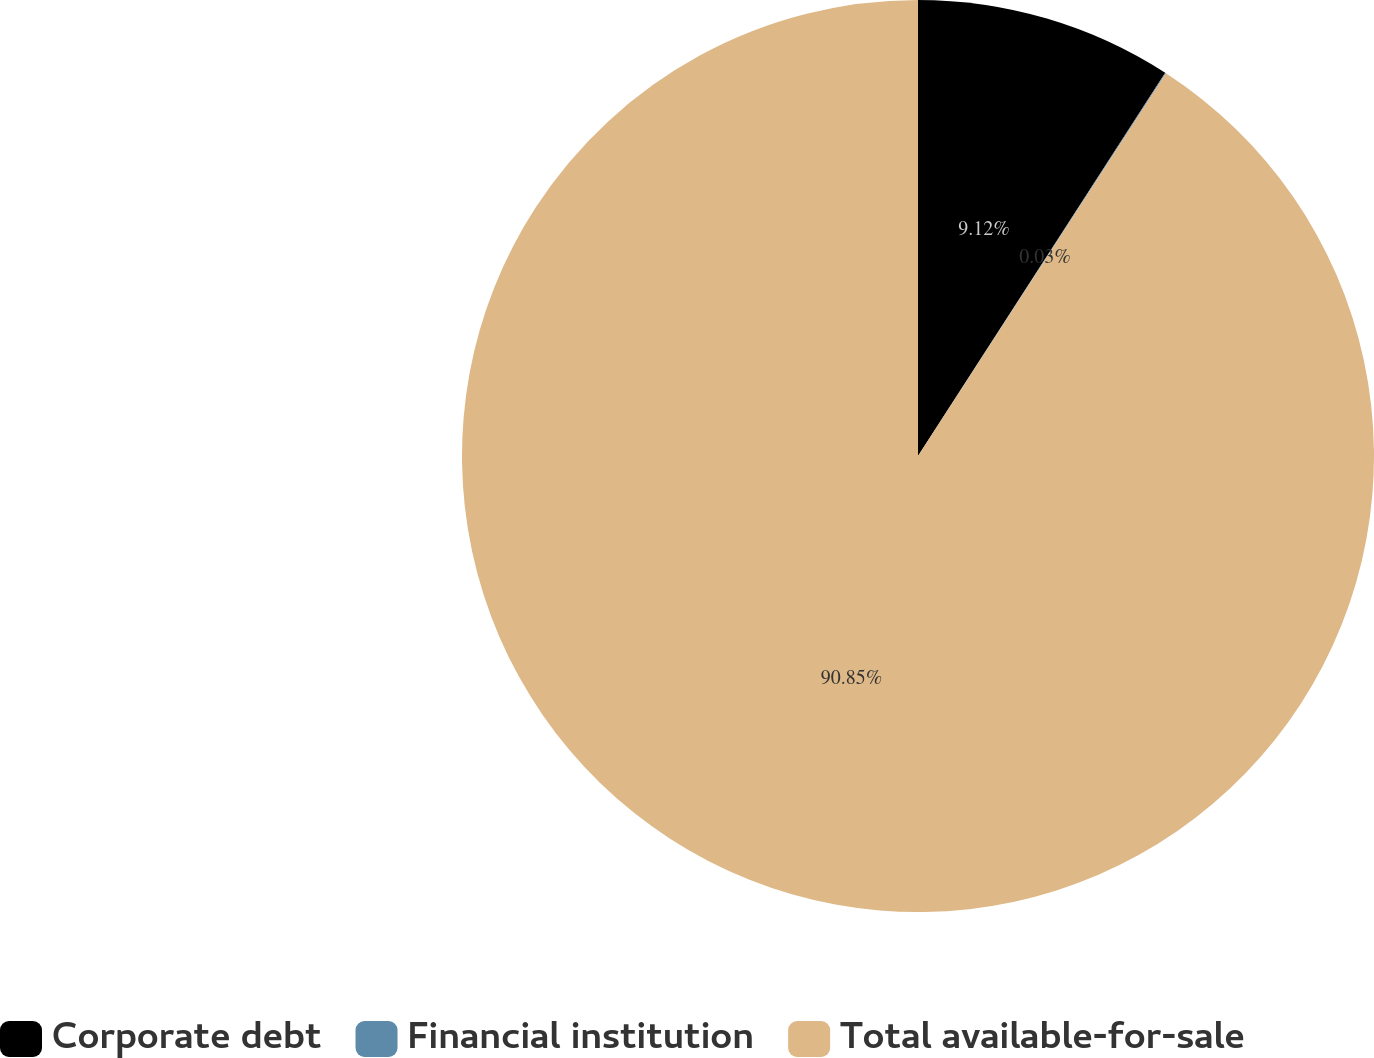Convert chart to OTSL. <chart><loc_0><loc_0><loc_500><loc_500><pie_chart><fcel>Corporate debt<fcel>Financial institution<fcel>Total available-for-sale<nl><fcel>9.12%<fcel>0.03%<fcel>90.85%<nl></chart> 